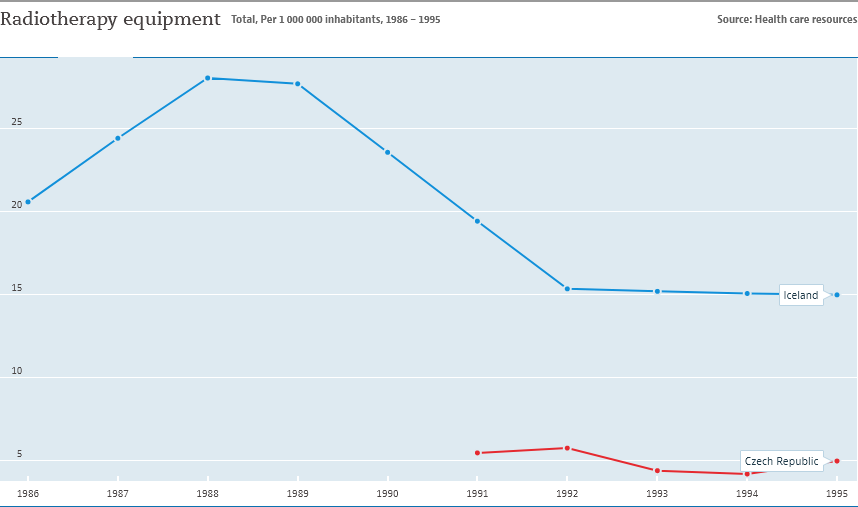How does the trend in Iceland compare with that of the Czech Republic in the same timeframe? Unlike Iceland’s declining trend, the graph shows a relatively stable trend for the Czech Republic with a slight increase in radiotherapy equipment from 1986 to 1995. It starts at around 2 per million inhabitants and slightly rises to approximately 2.5 per million by 1995. 